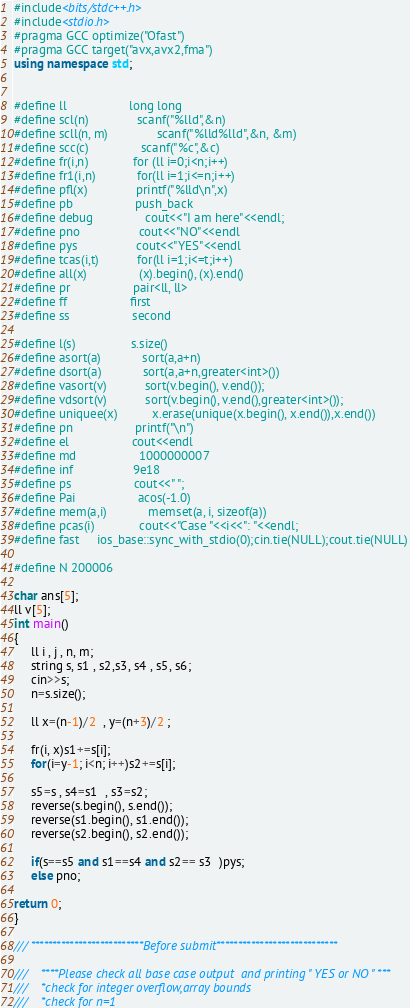<code> <loc_0><loc_0><loc_500><loc_500><_C++_>
#include<bits/stdc++.h>
#include<stdio.h>
#pragma GCC optimize("Ofast")
#pragma GCC target("avx,avx2,fma")
using namespace std;


#define ll                  long long
#define scl(n)              scanf("%lld",&n)
#define scll(n, m)              scanf("%lld%lld",&n, &m)
#define scc(c)	            scanf("%c",&c)
#define fr(i,n)             for (ll i=0;i<n;i++)
#define fr1(i,n)            for(ll i=1;i<=n;i++)
#define pfl(x)              printf("%lld\n",x)
#define pb                  push_back
#define debug               cout<<"I am here"<<endl;
#define pno                 cout<<"NO"<<endl
#define pys                 cout<<"YES"<<endl
#define tcas(i,t)           for(ll i=1;i<=t;i++)
#define all(x) 	            (x).begin(), (x).end()
#define pr                  pair<ll, ll>
#define ff                  first
#define ss                  second

#define l(s)                s.size()
#define asort(a)            sort(a,a+n)
#define dsort(a)            sort(a,a+n,greater<int>())
#define vasort(v)           sort(v.begin(), v.end());
#define vdsort(v)           sort(v.begin(), v.end(),greater<int>());
#define uniquee(x)          x.erase(unique(x.begin(), x.end()),x.end())
#define pn                  printf("\n")
#define el                  cout<<endl
#define md                  1000000007
#define inf                 9e18
#define ps                  cout<<" ";
#define Pai                  acos(-1.0)
#define mem(a,i)            memset(a, i, sizeof(a))
#define pcas(i)             cout<<"Case "<<i<<": "<<endl;
#define fast 	ios_base::sync_with_stdio(0);cin.tie(NULL);cout.tie(NULL)

#define N 200006

char ans[5];
ll v[5];
int main()
{
     ll i , j , n, m;
     string s, s1 , s2,s3, s4 , s5, s6;
     cin>>s;
     n=s.size();

     ll x=(n-1)/2  , y=(n+3)/2 ;

     fr(i, x)s1+=s[i];
     for(i=y-1; i<n; i++)s2+=s[i];

     s5=s , s4=s1  , s3=s2;
     reverse(s.begin(), s.end());
     reverse(s1.begin(), s1.end());
     reverse(s2.begin(), s2.end());

     if(s==s5 and s1==s4 and s2== s3  )pys;
     else pno;

return 0;
}

/// **************************Before submit****************************

///    ****Please check all base case output  and printing " YES or NO " ***
///    *check for integer overflow,array bounds
///    *check for n=1


</code> 